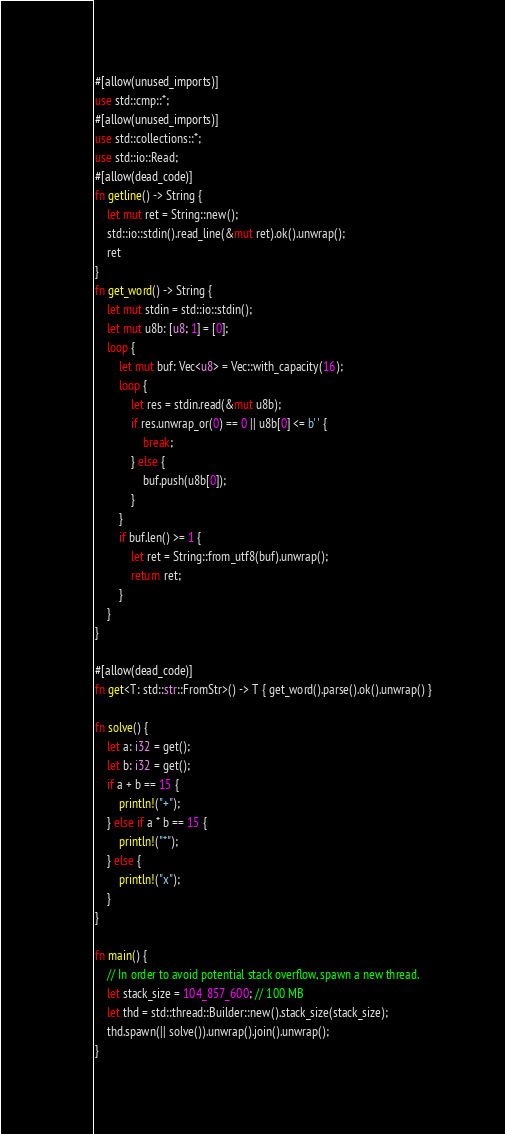Convert code to text. <code><loc_0><loc_0><loc_500><loc_500><_Rust_>#[allow(unused_imports)]
use std::cmp::*;
#[allow(unused_imports)]
use std::collections::*;
use std::io::Read;
#[allow(dead_code)]
fn getline() -> String {
    let mut ret = String::new();
    std::io::stdin().read_line(&mut ret).ok().unwrap();
    ret
}
fn get_word() -> String {
    let mut stdin = std::io::stdin();
    let mut u8b: [u8; 1] = [0];
    loop {
        let mut buf: Vec<u8> = Vec::with_capacity(16);
        loop {
            let res = stdin.read(&mut u8b);
            if res.unwrap_or(0) == 0 || u8b[0] <= b' ' {
                break;
            } else {
                buf.push(u8b[0]);
            }
        }
        if buf.len() >= 1 {
            let ret = String::from_utf8(buf).unwrap();
            return ret;
        }
    }
}

#[allow(dead_code)]
fn get<T: std::str::FromStr>() -> T { get_word().parse().ok().unwrap() }

fn solve() {
    let a: i32 = get();
    let b: i32 = get();
    if a + b == 15 {
        println!("+");
    } else if a * b == 15 {
        println!("*");
    } else {
        println!("x");
    }
}

fn main() {
    // In order to avoid potential stack overflow, spawn a new thread.
    let stack_size = 104_857_600; // 100 MB
    let thd = std::thread::Builder::new().stack_size(stack_size);
    thd.spawn(|| solve()).unwrap().join().unwrap();
}
</code> 